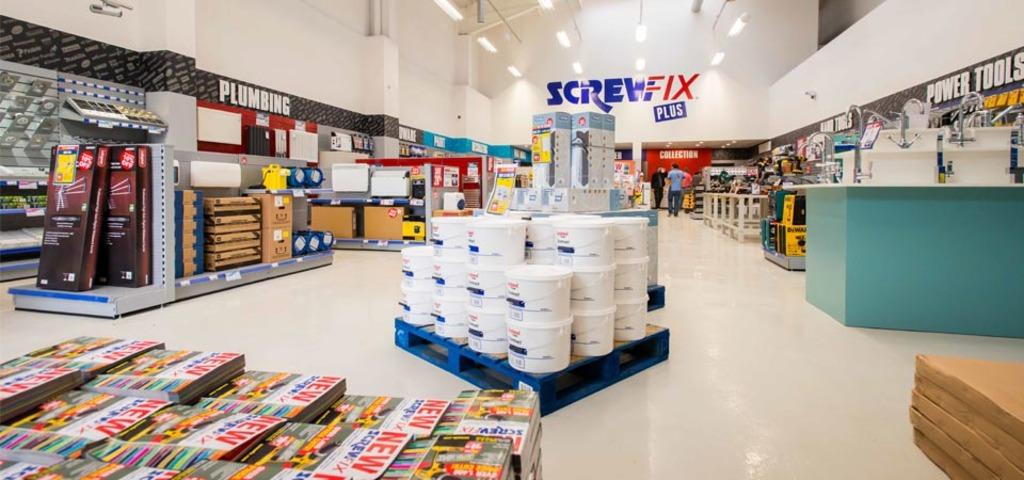<image>
Render a clear and concise summary of the photo. Large store with the giant words "Screw-Fix Plus" in the back. 